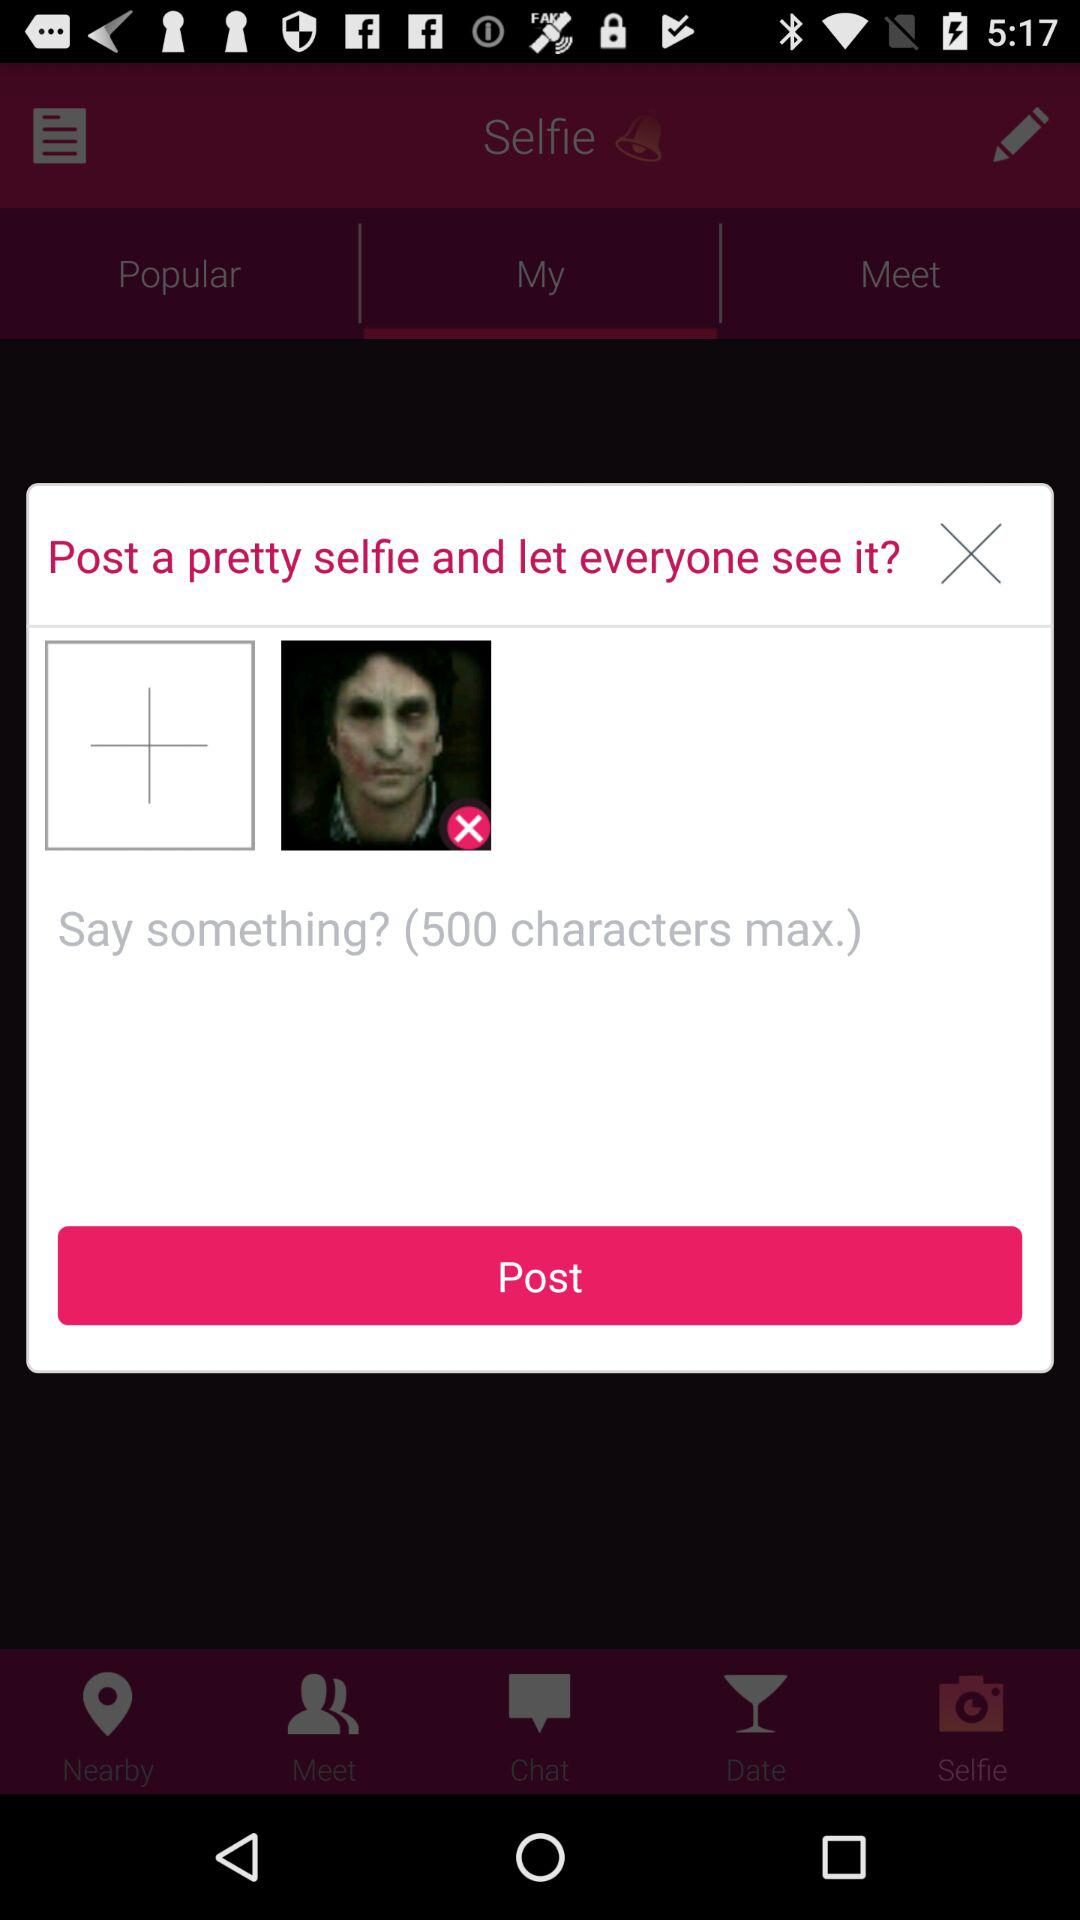What is the maximum number of characters I can write in the post? The maximum number of characters you can write in the post is 500. 